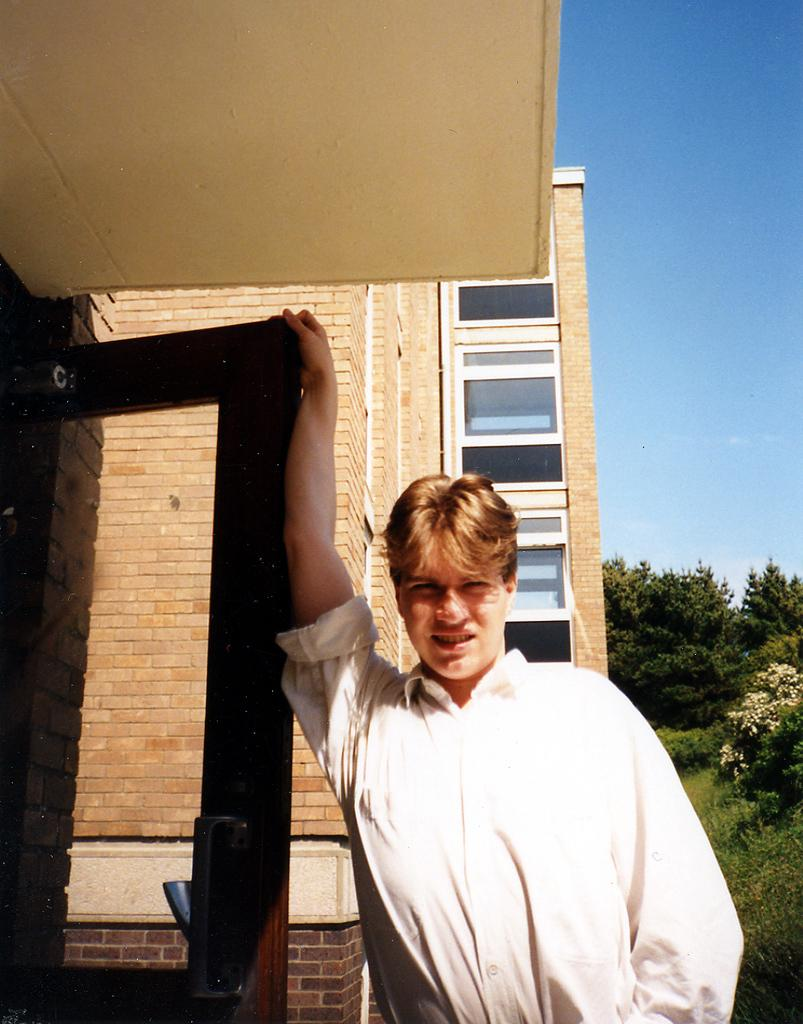What is the main subject of the image? There is a person standing in the image. What is the person holding in the image? The person is holding a door. What can be seen in the background of the image? There is a building, trees, and the sky visible in the background of the image. What type of brain can be seen in the image? There is no brain present in the image. Is there a fireman in the image? There is no fireman mentioned or visible in the image. 